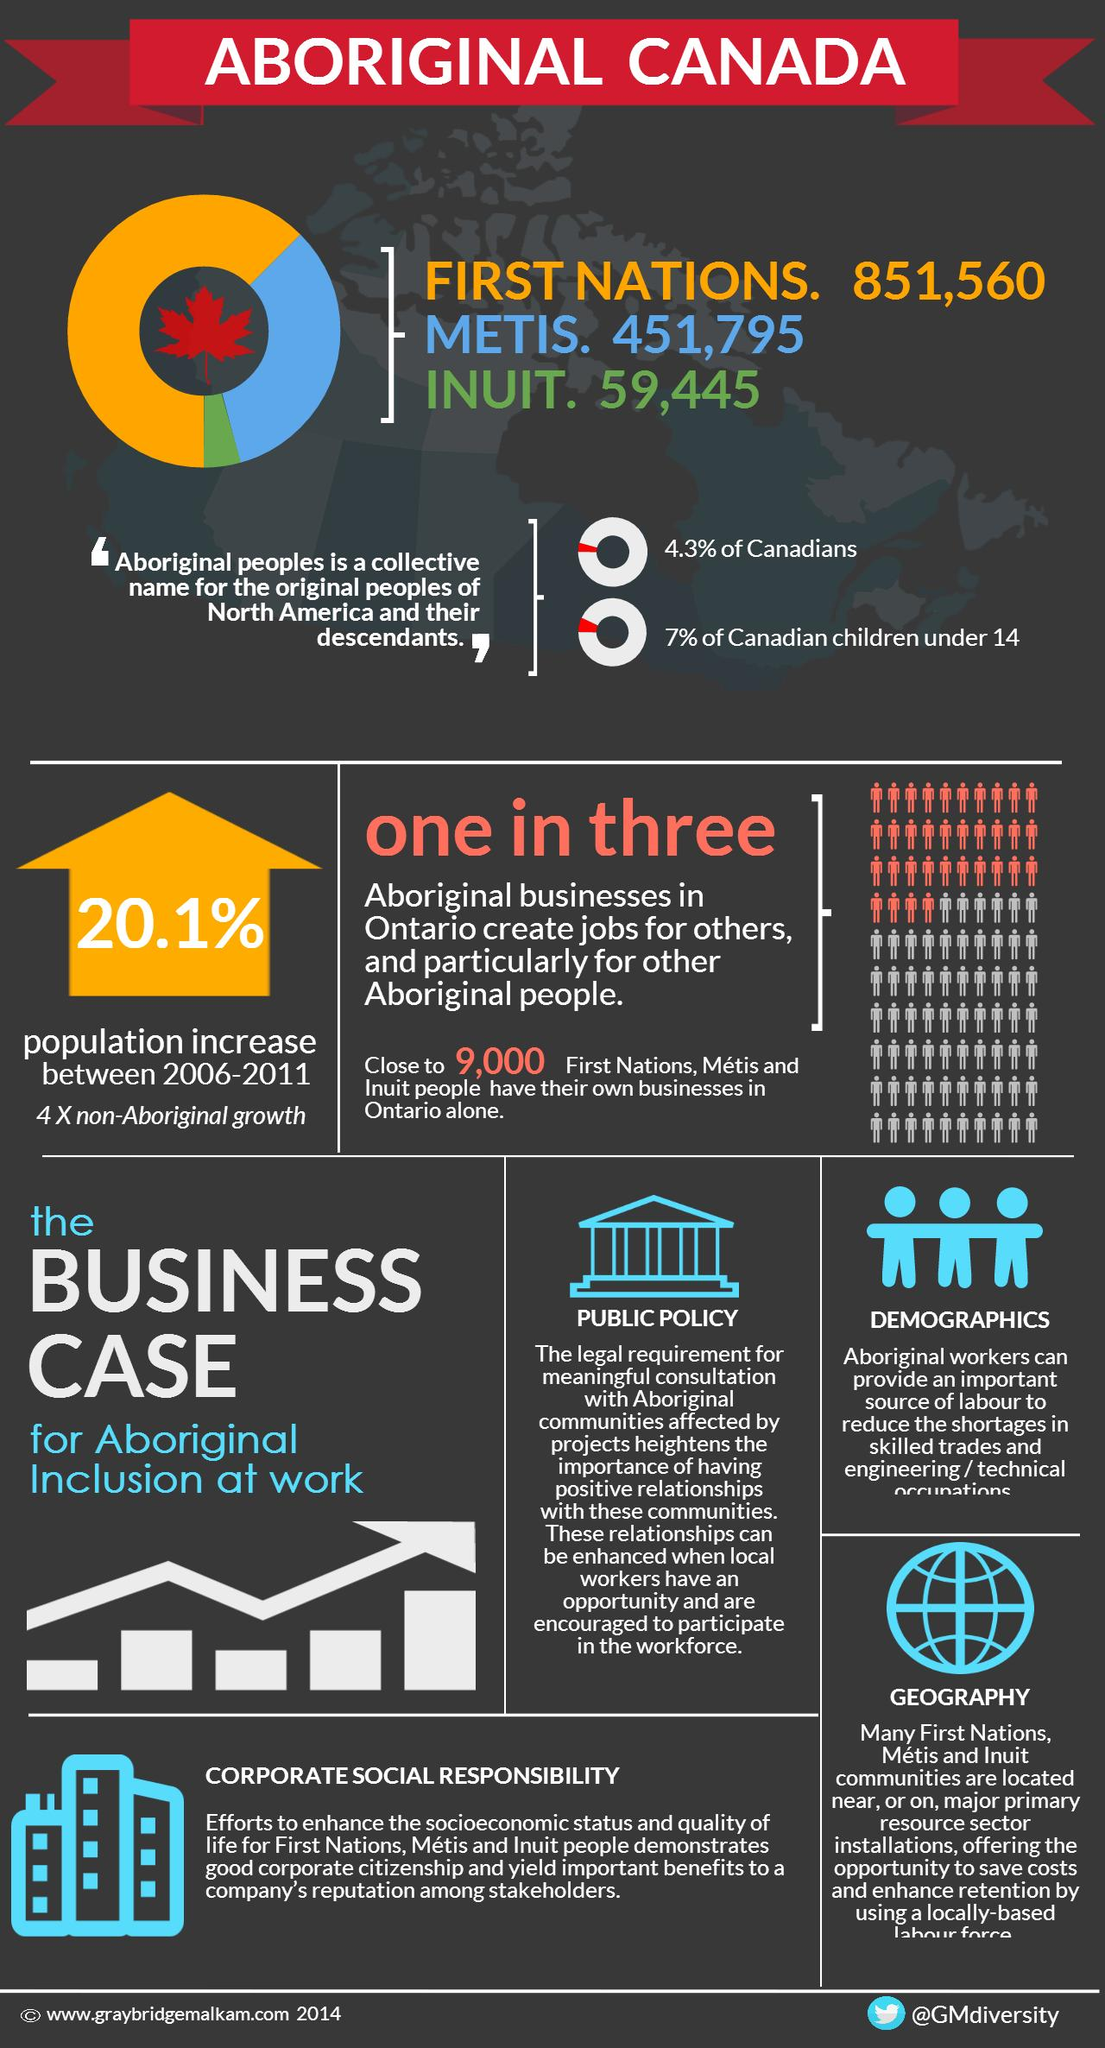Identify some key points in this picture. There are 511,240 people of Metis and Inuit ancestry living in Canada. 